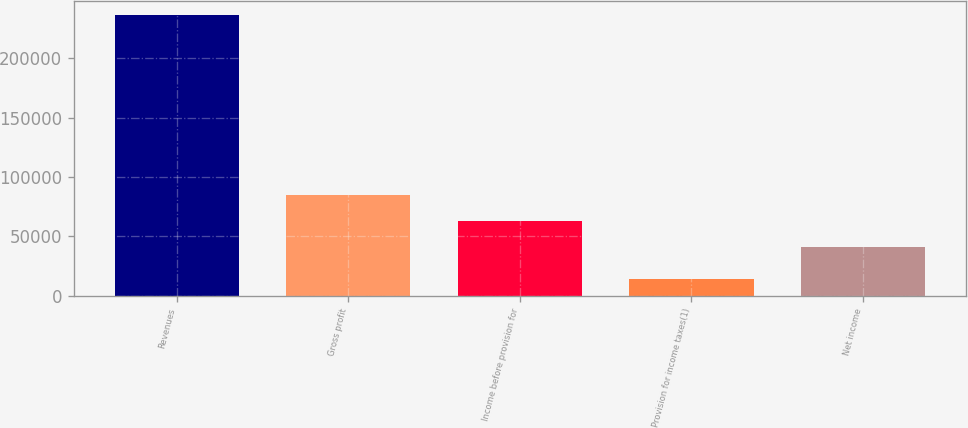Convert chart. <chart><loc_0><loc_0><loc_500><loc_500><bar_chart><fcel>Revenues<fcel>Gross profit<fcel>Income before provision for<fcel>Provision for income taxes(1)<fcel>Net income<nl><fcel>236285<fcel>85191.6<fcel>63003.3<fcel>14402<fcel>40815<nl></chart> 